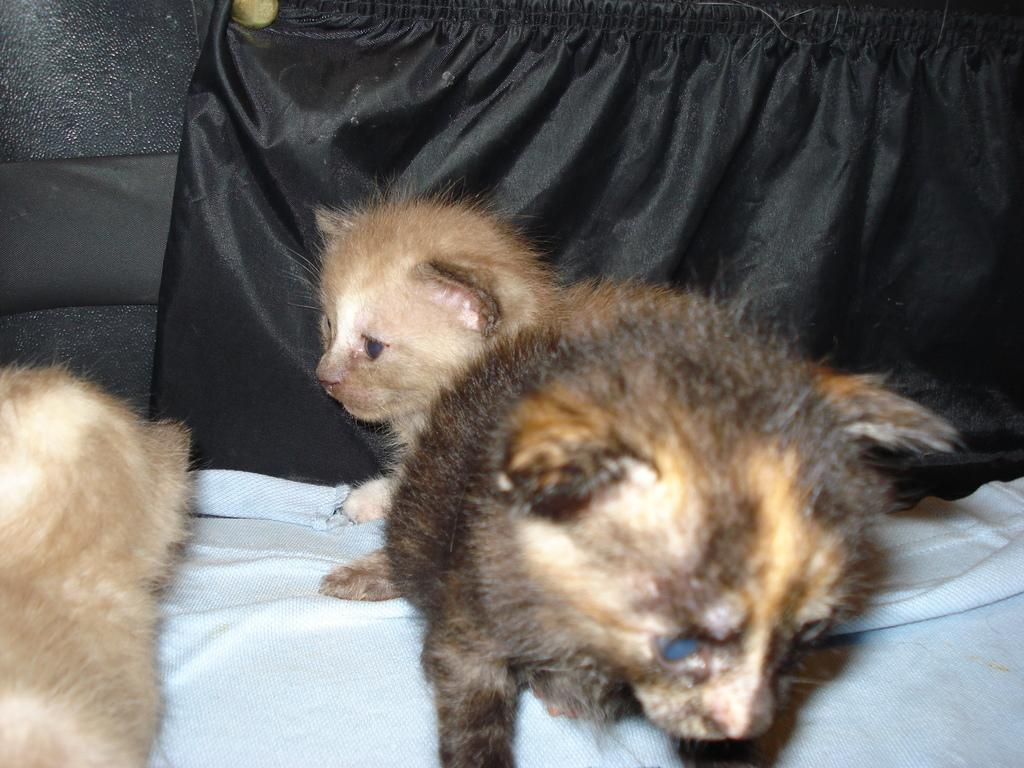What animals are in the foreground of the image? There are kittens in the foreground of the image. What type of curtain is in the background of the image? There is a black curtain in the background of the image. How much money is on the plate in the image? There is no plate or money present in the image; it features kittens and a black curtain. What type of cord is connected to the kittens in the image? There is no cord connected to the kittens in the image; they are simply sitting in the foreground. 